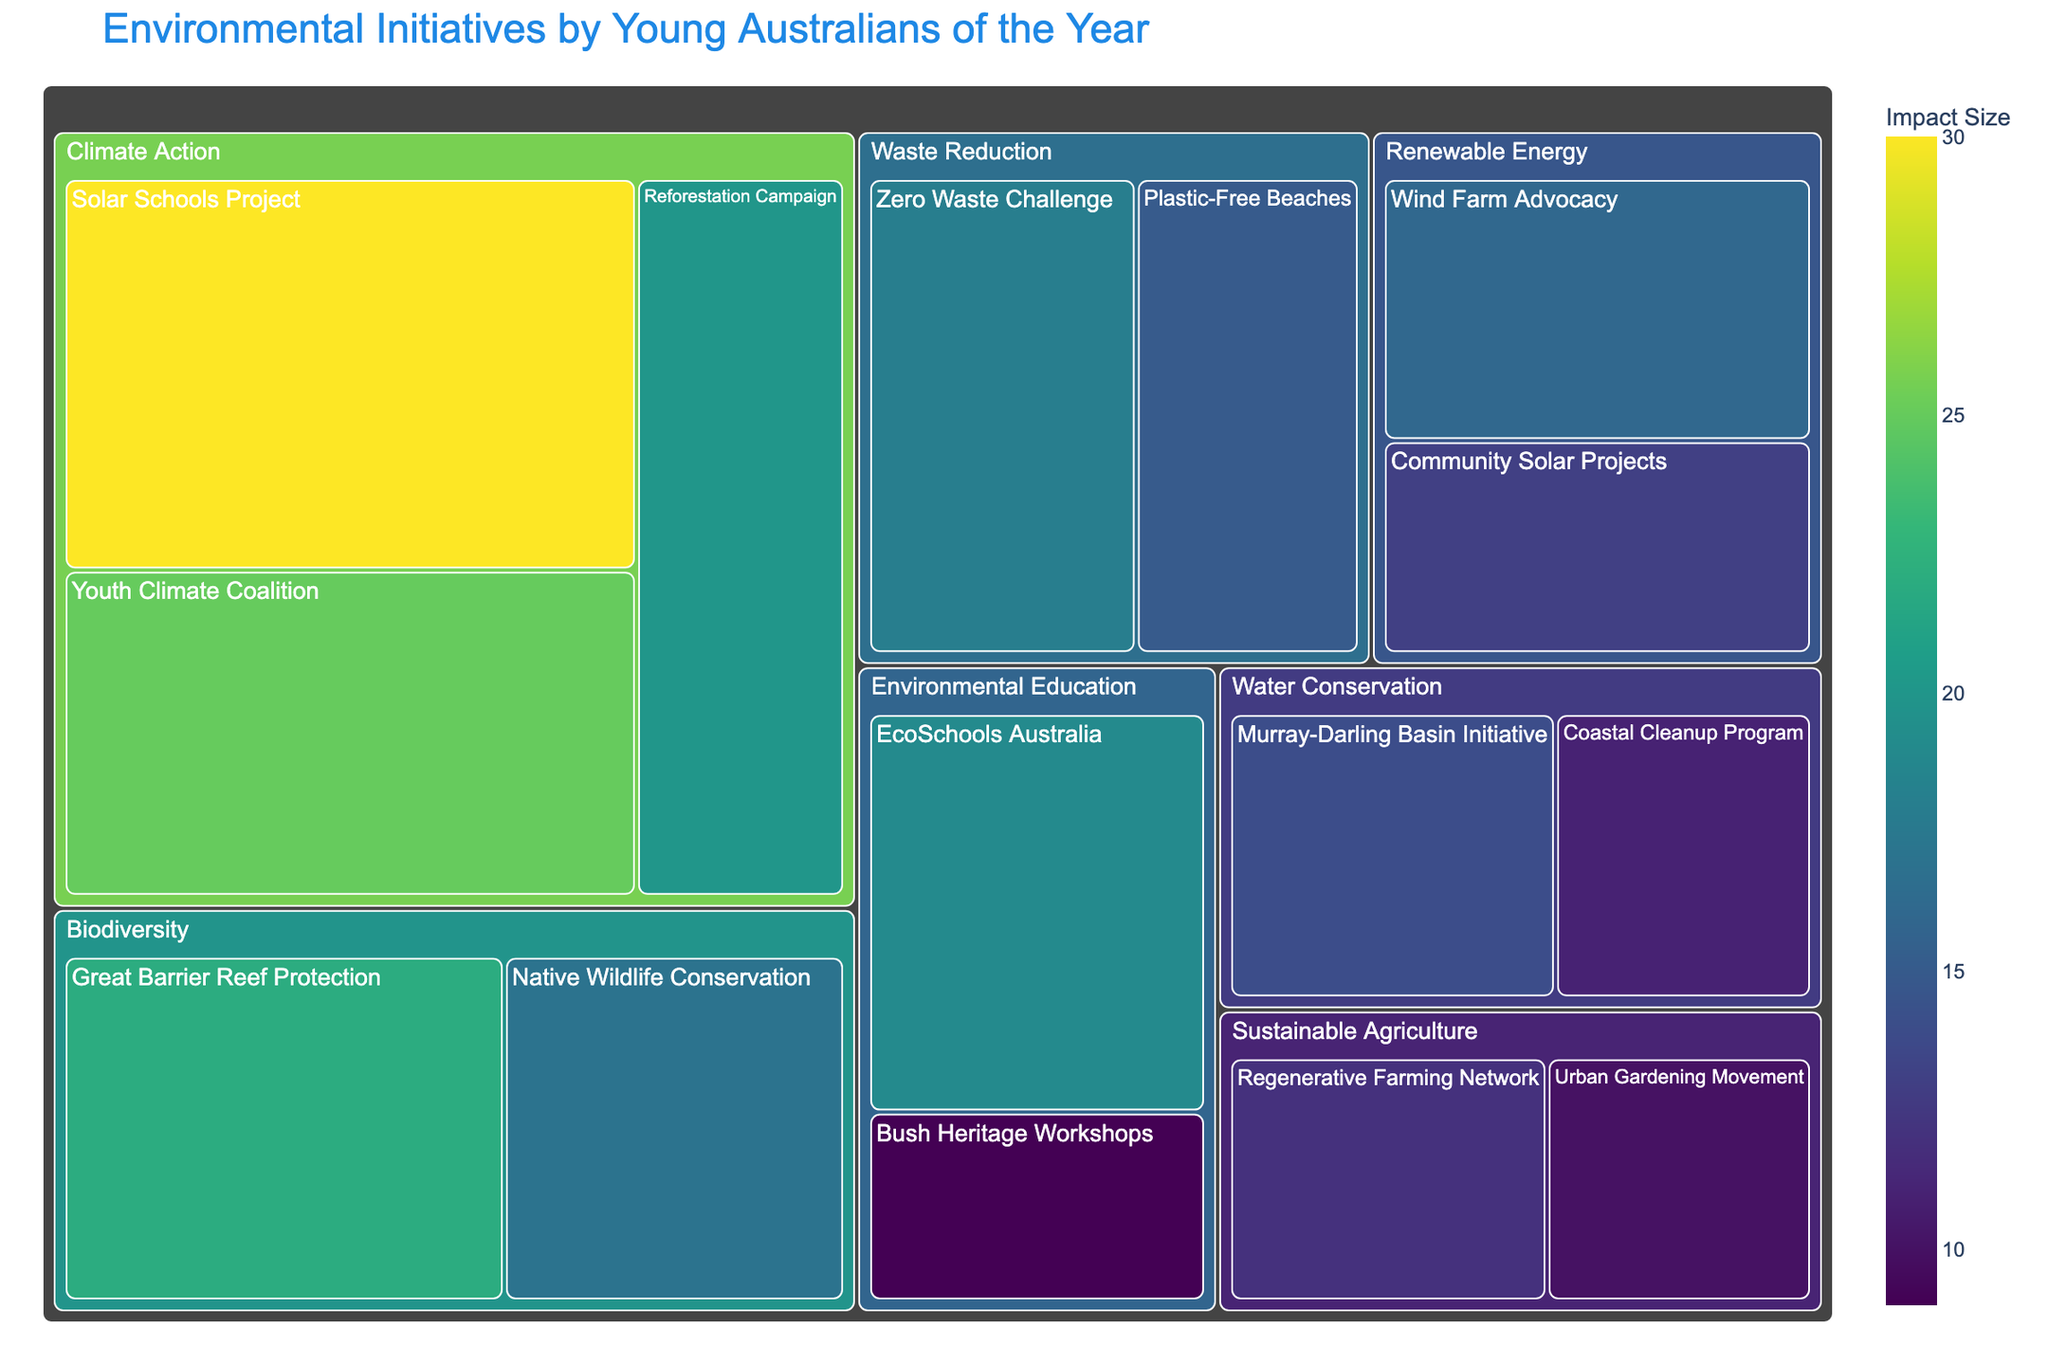What is the largest initiative in the Climate Action impact area? The Solar Schools Project has the largest impact size within the Climate Action category.
Answer: Solar Schools Project Which impact area has the smallest cumulative impact size? The sum of the impact sizes for each area is computed: Climate Action (30+25+20=75), Waste Reduction (18+15=33), Biodiversity (22+17=39), Sustainable Agriculture (12+10=22), Water Conservation (14+11=25), Renewable Energy (16+13=29), Environmental Education (19+9=28). Thus, Sustainable Agriculture has the smallest cumulative impact size.
Answer: Sustainable Agriculture Which initiative within Renewable Energy has a larger impact size? Within the Renewable Energy category, the impact sizes are Wind Farm Advocacy (16) and Community Solar Projects (13). Comparing these, Wind Farm Advocacy is larger.
Answer: Wind Farm Advocacy What is the average impact size across all initiatives in the Waste Reduction category? The impact sizes for Waste Reduction initiatives are 18 and 15. The average is calculated as (18 + 15)/2 = 16.5.
Answer: 16.5 Compare the impact sizes of EcoSchools Australia and Plastic-Free Beaches. Which one is larger? EcoSchools Australia's impact size is 19, and Plastic-Free Beaches' impact size is 15. Therefore, EcoSchools Australia is larger.
Answer: EcoSchools Australia How many initiatives are categorized under Biodiversity? There are two initiatives under Biodiversity: Great Barrier Reef Protection and Native Wildlife Conservation.
Answer: 2 Which initiative has the smallest impact size in the Environmental Education category? The initiatives in Environmental Education are EcoSchools Australia (19) and Bush Heritage Workshops (9). Bush Heritage Workshops has the smallest impact size.
Answer: Bush Heritage Workshops What is the cumulative impact size for all initiatives related to Water Conservation? The initiatives in Water Conservation are Murray-Darling Basin Initiative (14) and Coastal Cleanup Program (11). The cumulative impact size is 14 + 11 = 25.
Answer: 25 In the Climate Action impact area, what is the difference in impact size between the largest and smallest initiatives? The largest initiative in Climate Action is Solar Schools Project (30), and the smallest is Reforestation Campaign (20). The difference in impact size is 30 - 20 = 10.
Answer: 10 Which initiative has the largest impact size in the Biodiversity impact area? In the Biodiversity category, the initiatives are Great Barrier Reef Protection (22) and Native Wildlife Conservation (17). The Great Barrier Reef Protection has the largest impact size.
Answer: Great Barrier Reef Protection 